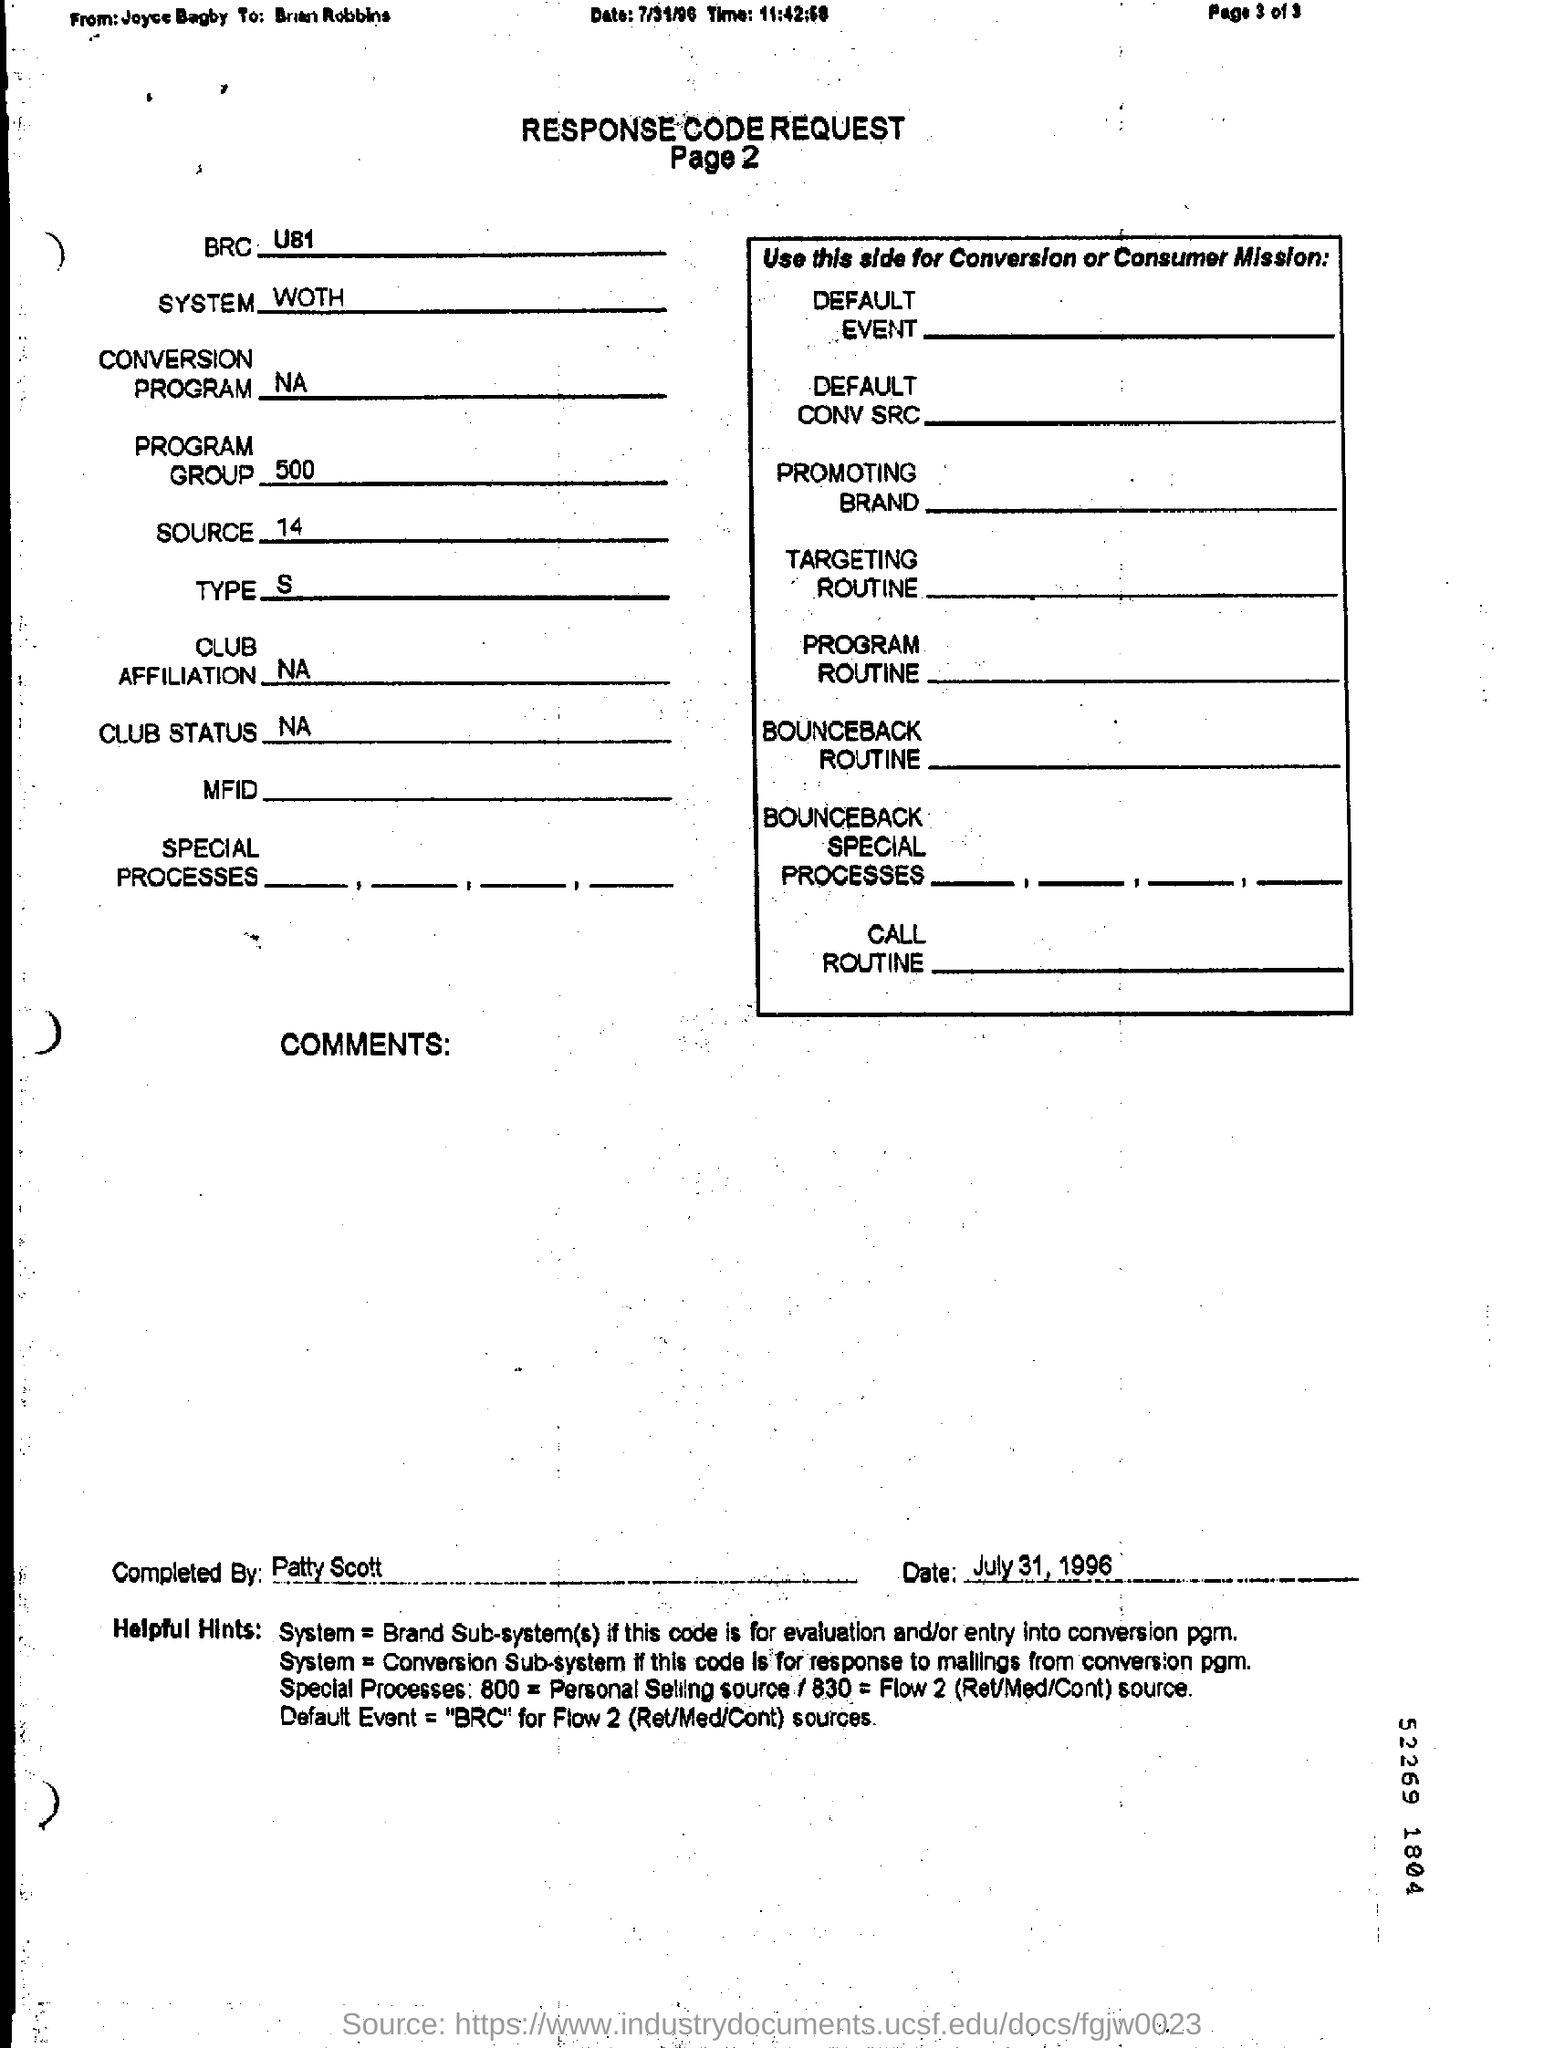Identify some key points in this picture. The source is 14.. July 31, 1996 is the date. What is the BRC? It is a question that has been asked numerous times, and its answer has eluded many. U81.. What is the type? It is declared that it is S.. What is the title of the document? RESPONSE CODE REQUEST.." is a request for information. 